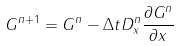Convert formula to latex. <formula><loc_0><loc_0><loc_500><loc_500>G ^ { n + 1 } = G ^ { n } - \Delta t D ^ { n } _ { x } \frac { \partial G ^ { n } } { \partial x }</formula> 